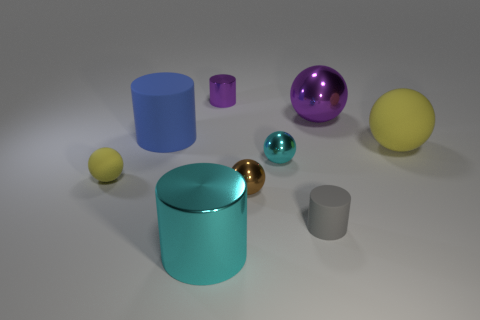There is a small metal object that is the same color as the large shiny cylinder; what is its shape?
Provide a short and direct response. Sphere. There is a tiny matte sphere; is it the same color as the small rubber object that is on the right side of the small metal cylinder?
Make the answer very short. No. There is a thing that is the same color as the small matte ball; what size is it?
Offer a very short reply. Large. The big object that is in front of the big purple ball and to the right of the tiny purple cylinder has what shape?
Your answer should be very brief. Sphere. Are there any big cyan shiny objects to the left of the big blue thing?
Your response must be concise. No. The purple object that is the same shape as the tiny brown thing is what size?
Provide a succinct answer. Large. Is there anything else that is the same size as the cyan sphere?
Your answer should be very brief. Yes. Do the gray matte object and the big yellow rubber thing have the same shape?
Your response must be concise. No. There is a cyan object left of the tiny metallic thing that is behind the large yellow thing; what size is it?
Your answer should be very brief. Large. There is a large metal thing that is the same shape as the tiny cyan shiny thing; what color is it?
Your answer should be very brief. Purple. 